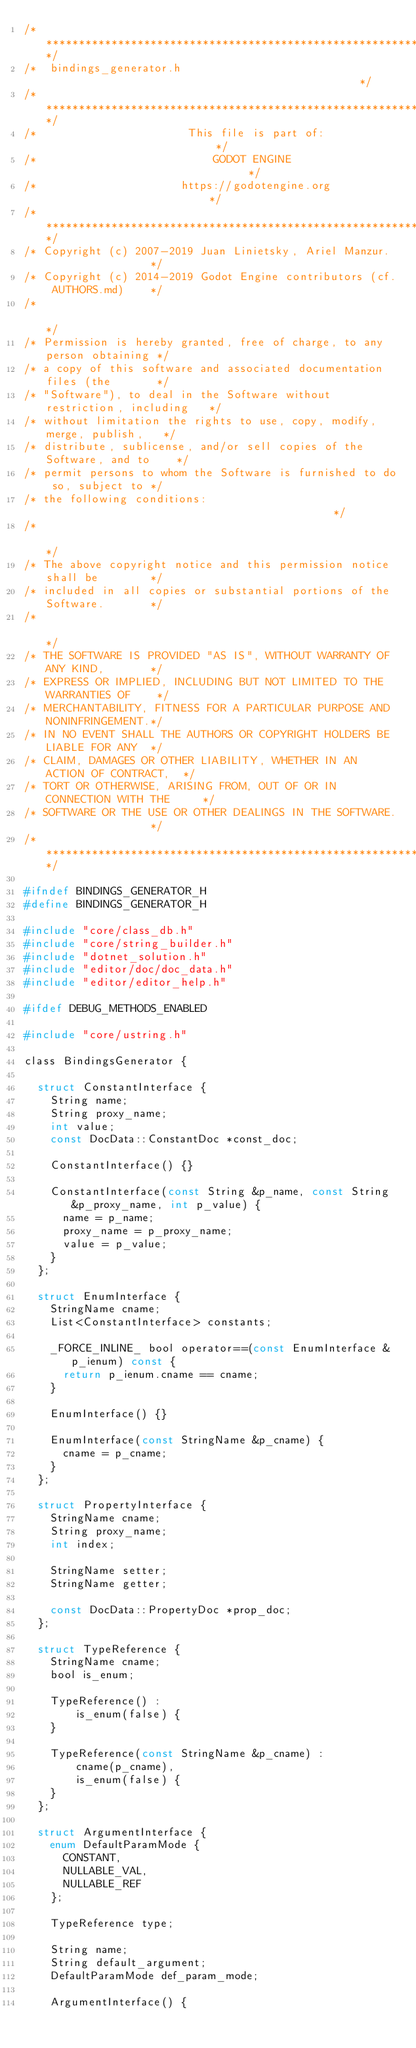<code> <loc_0><loc_0><loc_500><loc_500><_C_>/*************************************************************************/
/*  bindings_generator.h                                                 */
/*************************************************************************/
/*                       This file is part of:                           */
/*                           GODOT ENGINE                                */
/*                      https://godotengine.org                          */
/*************************************************************************/
/* Copyright (c) 2007-2019 Juan Linietsky, Ariel Manzur.                 */
/* Copyright (c) 2014-2019 Godot Engine contributors (cf. AUTHORS.md)    */
/*                                                                       */
/* Permission is hereby granted, free of charge, to any person obtaining */
/* a copy of this software and associated documentation files (the       */
/* "Software"), to deal in the Software without restriction, including   */
/* without limitation the rights to use, copy, modify, merge, publish,   */
/* distribute, sublicense, and/or sell copies of the Software, and to    */
/* permit persons to whom the Software is furnished to do so, subject to */
/* the following conditions:                                             */
/*                                                                       */
/* The above copyright notice and this permission notice shall be        */
/* included in all copies or substantial portions of the Software.       */
/*                                                                       */
/* THE SOFTWARE IS PROVIDED "AS IS", WITHOUT WARRANTY OF ANY KIND,       */
/* EXPRESS OR IMPLIED, INCLUDING BUT NOT LIMITED TO THE WARRANTIES OF    */
/* MERCHANTABILITY, FITNESS FOR A PARTICULAR PURPOSE AND NONINFRINGEMENT.*/
/* IN NO EVENT SHALL THE AUTHORS OR COPYRIGHT HOLDERS BE LIABLE FOR ANY  */
/* CLAIM, DAMAGES OR OTHER LIABILITY, WHETHER IN AN ACTION OF CONTRACT,  */
/* TORT OR OTHERWISE, ARISING FROM, OUT OF OR IN CONNECTION WITH THE     */
/* SOFTWARE OR THE USE OR OTHER DEALINGS IN THE SOFTWARE.                */
/*************************************************************************/

#ifndef BINDINGS_GENERATOR_H
#define BINDINGS_GENERATOR_H

#include "core/class_db.h"
#include "core/string_builder.h"
#include "dotnet_solution.h"
#include "editor/doc/doc_data.h"
#include "editor/editor_help.h"

#ifdef DEBUG_METHODS_ENABLED

#include "core/ustring.h"

class BindingsGenerator {

	struct ConstantInterface {
		String name;
		String proxy_name;
		int value;
		const DocData::ConstantDoc *const_doc;

		ConstantInterface() {}

		ConstantInterface(const String &p_name, const String &p_proxy_name, int p_value) {
			name = p_name;
			proxy_name = p_proxy_name;
			value = p_value;
		}
	};

	struct EnumInterface {
		StringName cname;
		List<ConstantInterface> constants;

		_FORCE_INLINE_ bool operator==(const EnumInterface &p_ienum) const {
			return p_ienum.cname == cname;
		}

		EnumInterface() {}

		EnumInterface(const StringName &p_cname) {
			cname = p_cname;
		}
	};

	struct PropertyInterface {
		StringName cname;
		String proxy_name;
		int index;

		StringName setter;
		StringName getter;

		const DocData::PropertyDoc *prop_doc;
	};

	struct TypeReference {
		StringName cname;
		bool is_enum;

		TypeReference() :
				is_enum(false) {
		}

		TypeReference(const StringName &p_cname) :
				cname(p_cname),
				is_enum(false) {
		}
	};

	struct ArgumentInterface {
		enum DefaultParamMode {
			CONSTANT,
			NULLABLE_VAL,
			NULLABLE_REF
		};

		TypeReference type;

		String name;
		String default_argument;
		DefaultParamMode def_param_mode;

		ArgumentInterface() {</code> 